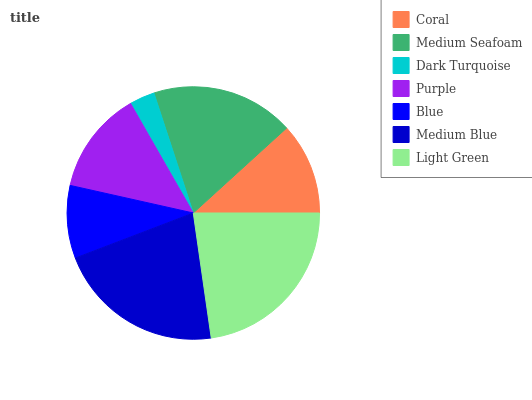Is Dark Turquoise the minimum?
Answer yes or no. Yes. Is Light Green the maximum?
Answer yes or no. Yes. Is Medium Seafoam the minimum?
Answer yes or no. No. Is Medium Seafoam the maximum?
Answer yes or no. No. Is Medium Seafoam greater than Coral?
Answer yes or no. Yes. Is Coral less than Medium Seafoam?
Answer yes or no. Yes. Is Coral greater than Medium Seafoam?
Answer yes or no. No. Is Medium Seafoam less than Coral?
Answer yes or no. No. Is Purple the high median?
Answer yes or no. Yes. Is Purple the low median?
Answer yes or no. Yes. Is Dark Turquoise the high median?
Answer yes or no. No. Is Medium Seafoam the low median?
Answer yes or no. No. 